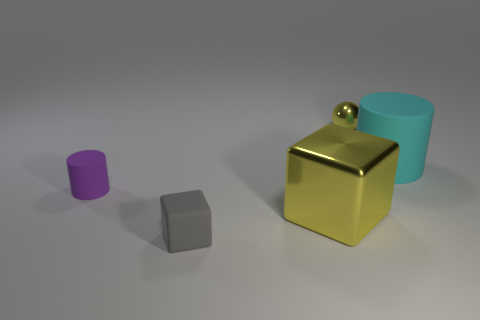What is the size of the other object that is the same color as the large metallic object?
Offer a very short reply. Small. Are there any gray rubber things behind the gray object?
Your answer should be very brief. No. What number of objects are either small brown balls or matte objects?
Offer a very short reply. 3. How many other objects are the same size as the gray thing?
Ensure brevity in your answer.  2. How many objects are on the left side of the tiny metallic thing and to the right of the gray thing?
Your answer should be very brief. 1. Do the cylinder that is in front of the cyan rubber cylinder and the cylinder behind the small purple thing have the same size?
Give a very brief answer. No. There is a cylinder left of the small gray block; what size is it?
Your answer should be compact. Small. What number of things are either yellow shiny things that are on the right side of the large metallic block or small metallic objects on the right side of the small purple matte thing?
Make the answer very short. 1. Is there anything else that is the same color as the sphere?
Offer a terse response. Yes. Are there the same number of tiny rubber things right of the small matte cube and gray blocks that are right of the metallic ball?
Offer a terse response. Yes. 